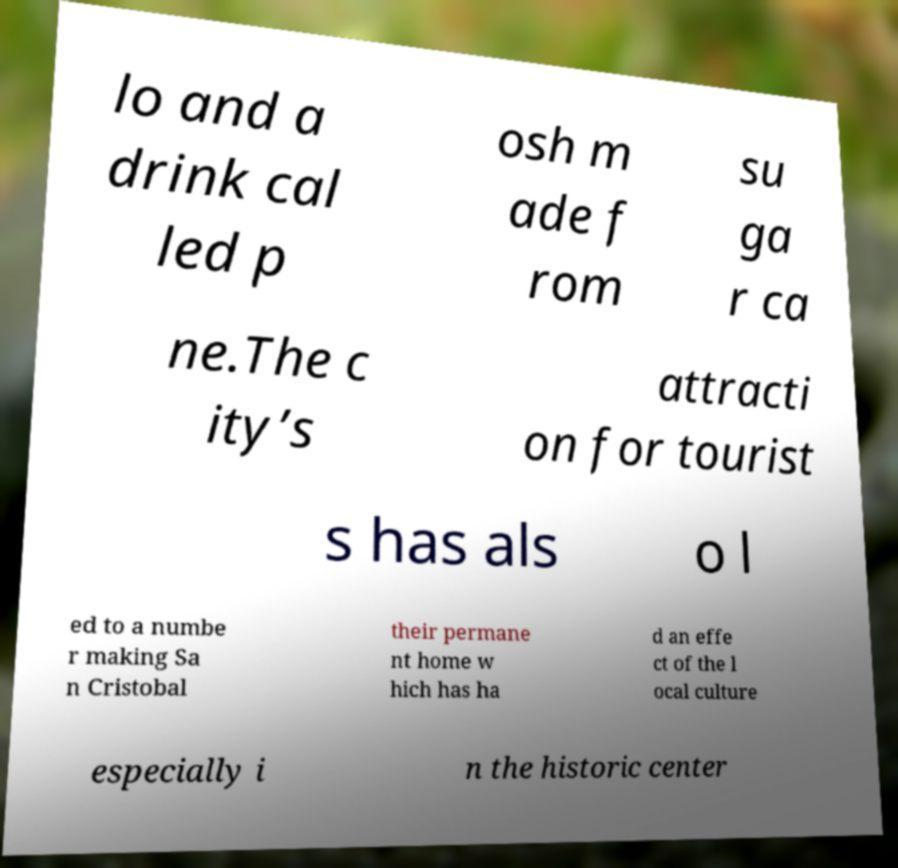Can you read and provide the text displayed in the image?This photo seems to have some interesting text. Can you extract and type it out for me? lo and a drink cal led p osh m ade f rom su ga r ca ne.The c ity’s attracti on for tourist s has als o l ed to a numbe r making Sa n Cristobal their permane nt home w hich has ha d an effe ct of the l ocal culture especially i n the historic center 